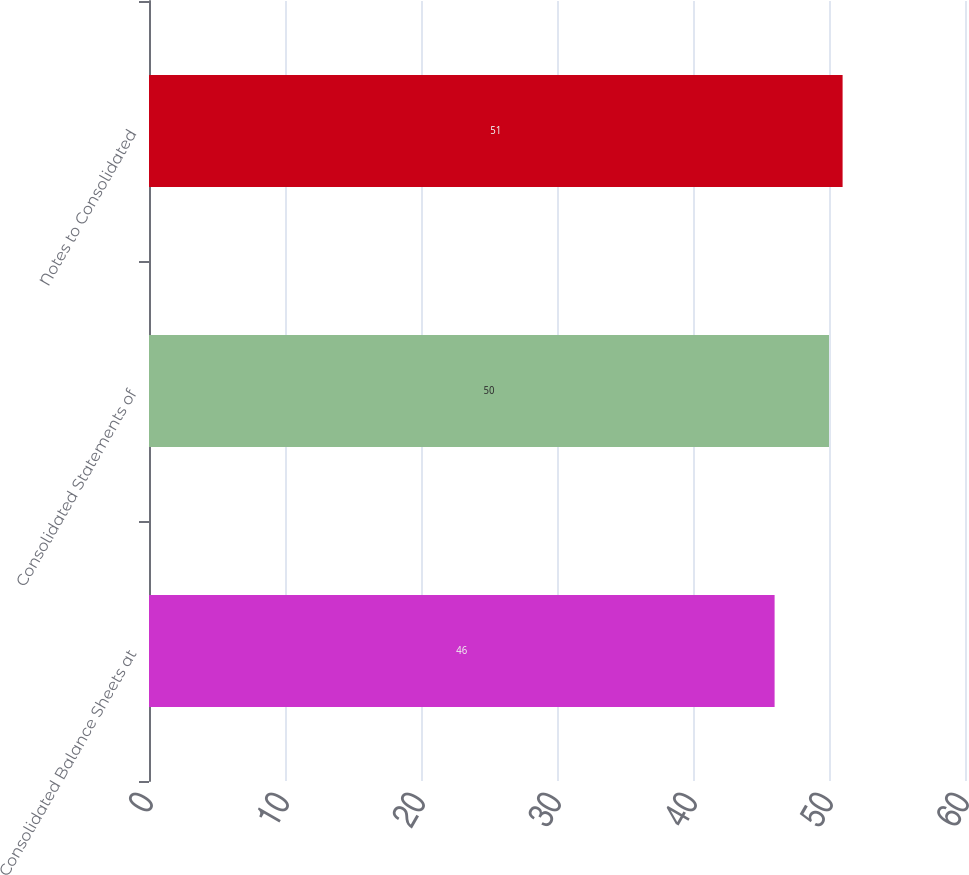Convert chart to OTSL. <chart><loc_0><loc_0><loc_500><loc_500><bar_chart><fcel>Consolidated Balance Sheets at<fcel>Consolidated Statements of<fcel>Notes to Consolidated<nl><fcel>46<fcel>50<fcel>51<nl></chart> 